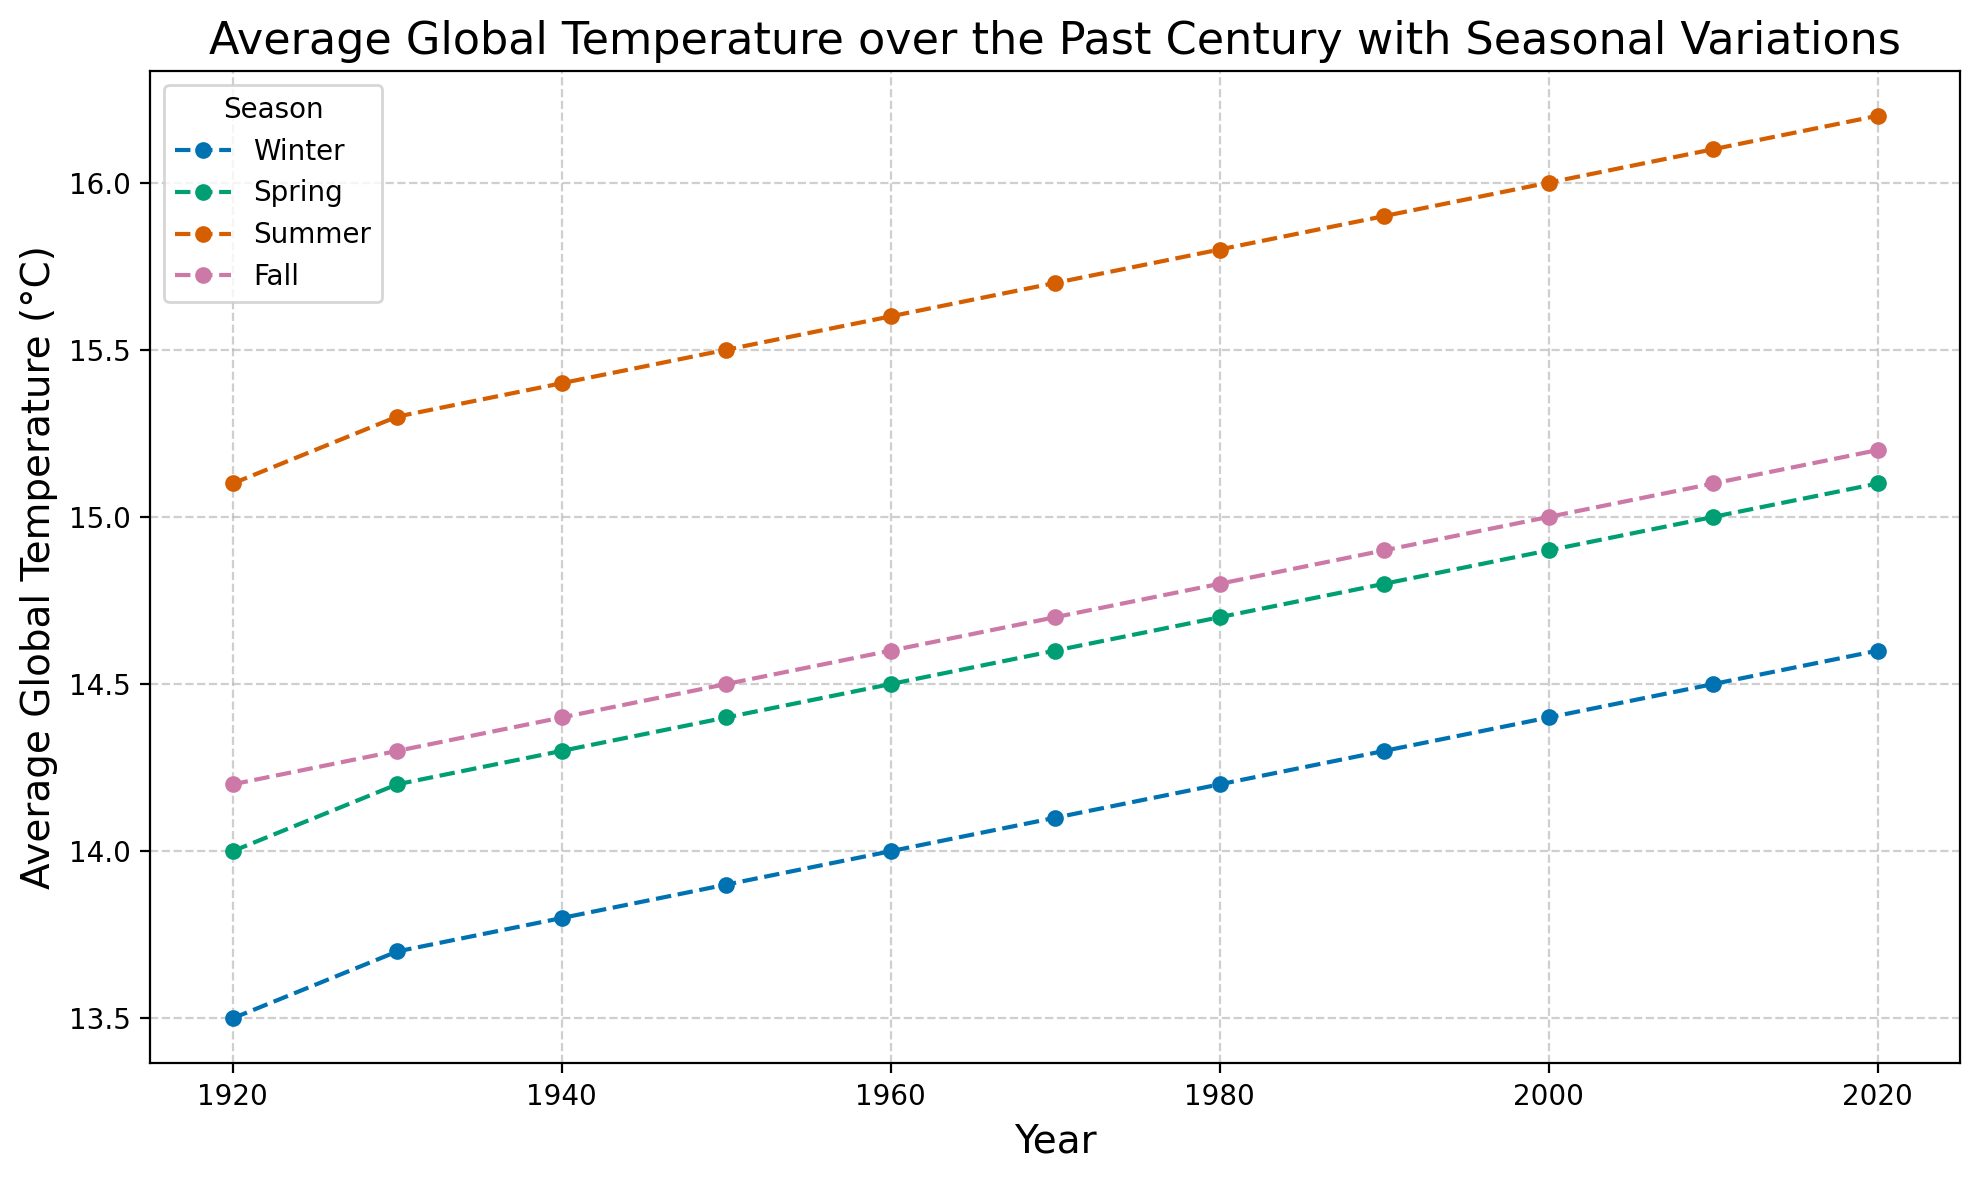What's the average global temperature in Winter in 1950 and 1960? The temperatures in Winter for 1950 and 1960 are 13.9°C and 14.0°C. Adding these, we get 13.9 + 14.0 = 27.9. The average is 27.9 / 2 = 13.95.
Answer: 13.95°C Which season had the highest temperature in the year 2020? Looking at the data for each season in 2020: Winter (14.6°C), Spring (15.1°C), Summer (16.2°C), and Fall (15.2°C). The highest temperature was in Summer at 16.2°C.
Answer: Summer Did the average global temperature increase more in Winter or Summer from 1920 to 2020? In Winter, the temperature increased from 13.5°C to 14.6°C, a difference of 1.1°C. In Summer, it increased from 15.1°C to 16.2°C, a difference of 1.1°C. Both seasons saw the same increase.
Answer: Both are equal What is the temperature difference between Spring and Fall in 1980? The temperatures in Spring and Fall in 1980 are 14.7°C and 14.8°C respectively. The difference is 14.8 - 14.7 = 0.1.
Answer: 0.1°C In which season did the average global temperature consistently increase every decade from 1920 to 2020? Observing the temperatures across decades in each season, we can see a consistent increase in all four seasons: Winter, Spring, Summer, and Fall.
Answer: All seasons What was the decadal increase rate of Summer temperatures from 1920 to 2020? From 1920 (15.1°C) to 2020 (16.2°C), the temperature increase is 16.2 - 15.1 = 1.1°C over 10 decades, so the average decadal increase rate is 1.1 / 10 = 0.11.
Answer: 0.11°C per decade Between 1950 and 1960, which season had a higher average temperature? In 1950, seasonal temperatures: Winter (13.9°C), Spring (14.4°C), Summer (15.5°C), Fall (14.5°C). In 1960, Winter (14.0°C), Spring (14.5°C), Summer (15.6°C), Fall (14.6°C). Summer has the highest in both years and its average for the decade is higher.
Answer: Summer Which year showed the biggest temperature difference between Winter and Summer? Comparing the differences: 1920 (1.6°C), 1930 (1.6°C), 1940 (1.6°C), 1950 (1.6°C), 1960 (1.6°C), 1970 (1.6°C), 1980 (1.6°C), 1990 (1.6°C), 2000 (1.6°C), 2010 (1.6°C), 2020 (1.6°C). All years have the same difference of 1.6°C.
Answer: All years have the same difference of 1.6°C 